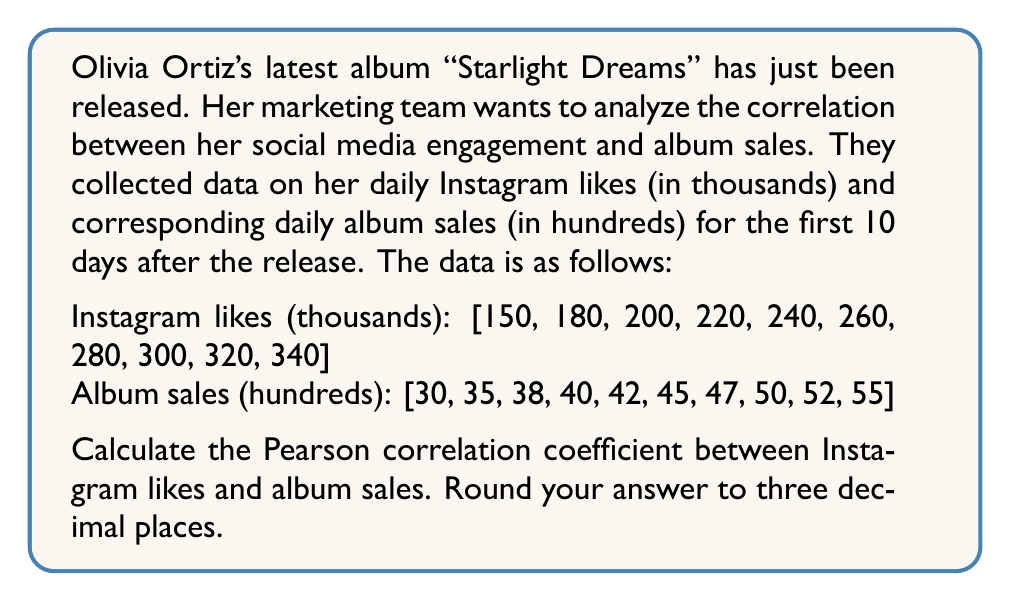What is the answer to this math problem? To calculate the Pearson correlation coefficient, we'll use the formula:

$$ r = \frac{\sum_{i=1}^{n} (x_i - \bar{x})(y_i - \bar{y})}{\sqrt{\sum_{i=1}^{n} (x_i - \bar{x})^2} \sqrt{\sum_{i=1}^{n} (y_i - \bar{y})^2}} $$

Where:
$x_i$ represents Instagram likes
$y_i$ represents album sales
$\bar{x}$ and $\bar{y}$ are the means of $x$ and $y$ respectively

Step 1: Calculate the means
$\bar{x} = \frac{150 + 180 + 200 + 220 + 240 + 260 + 280 + 300 + 320 + 340}{10} = 249$
$\bar{y} = \frac{30 + 35 + 38 + 40 + 42 + 45 + 47 + 50 + 52 + 55}{10} = 43.4$

Step 2: Calculate $(x_i - \bar{x})$, $(y_i - \bar{y})$, $(x_i - \bar{x})^2$, $(y_i - \bar{y})^2$, and $(x_i - \bar{x})(y_i - \bar{y})$

Step 3: Sum up the calculated values
$\sum (x_i - \bar{x})(y_i - \bar{y}) = 1799$
$\sum (x_i - \bar{x})^2 = 36100$
$\sum (y_i - \bar{y})^2 = 410.4$

Step 4: Apply the formula
$$ r = \frac{1799}{\sqrt{36100} \sqrt{410.4}} = \frac{1799}{191.57 \times 20.26} = 0.9934 $$

Step 5: Round to three decimal places
$r \approx 0.993$
Answer: 0.993 